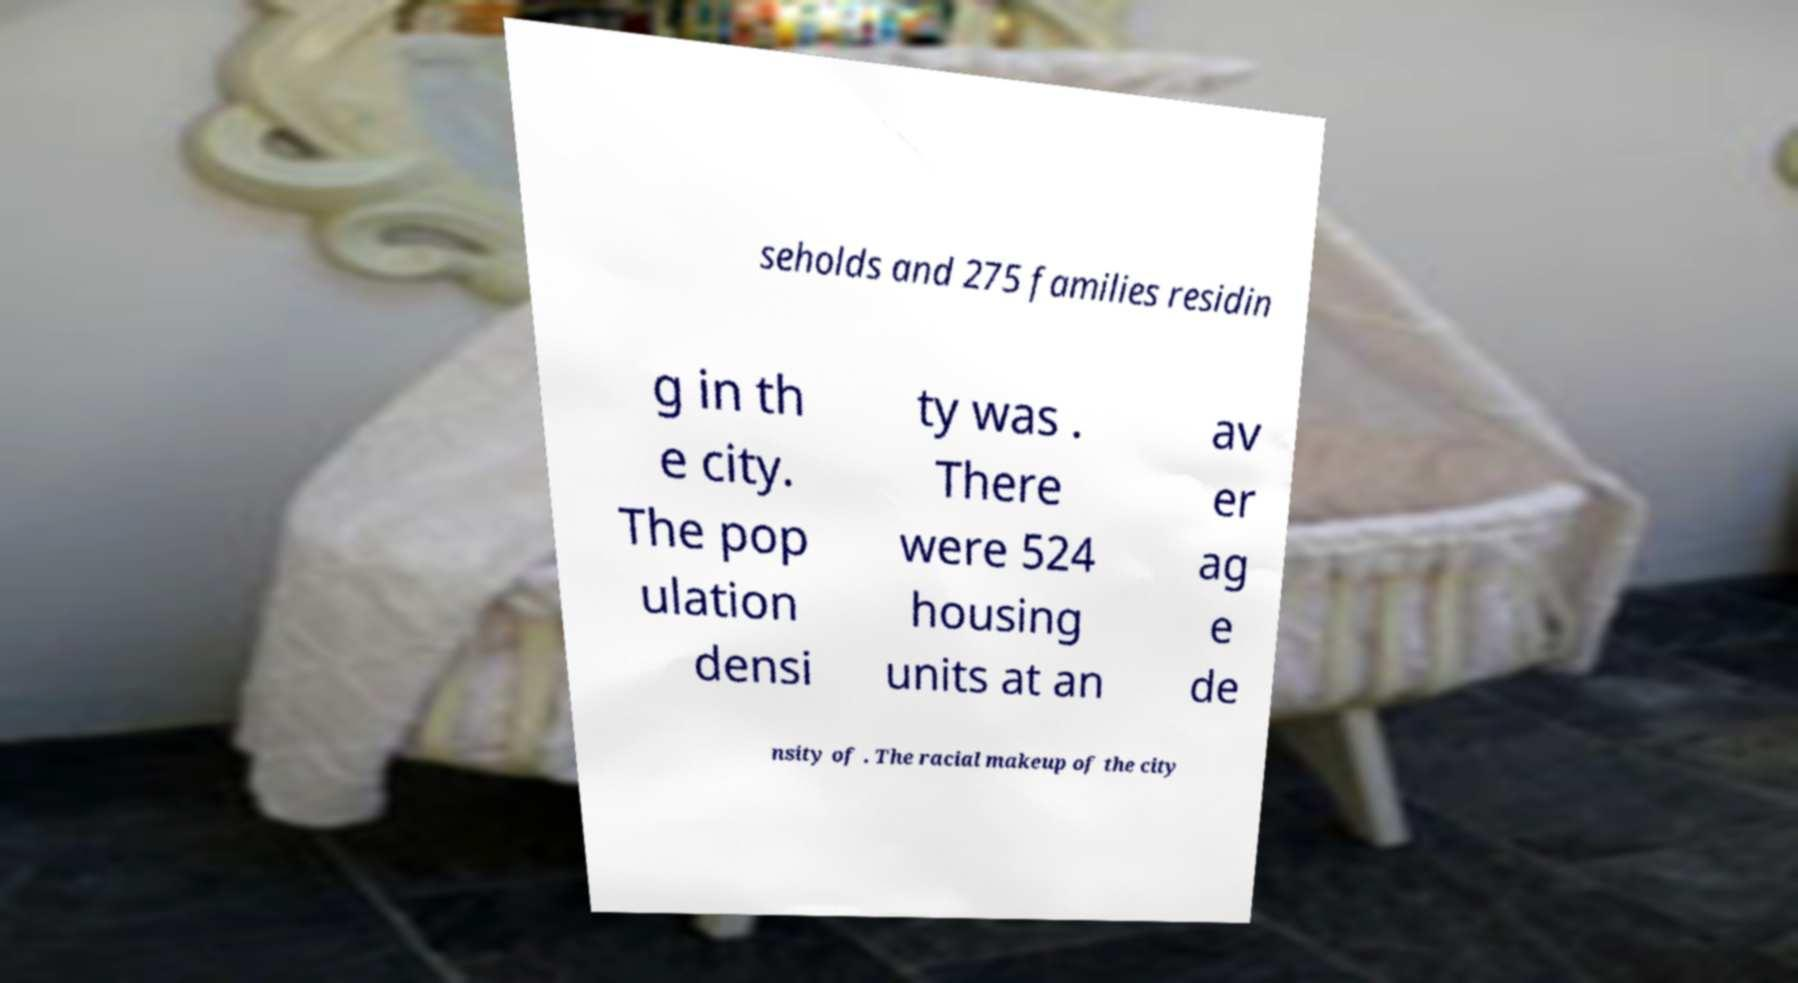What messages or text are displayed in this image? I need them in a readable, typed format. seholds and 275 families residin g in th e city. The pop ulation densi ty was . There were 524 housing units at an av er ag e de nsity of . The racial makeup of the city 